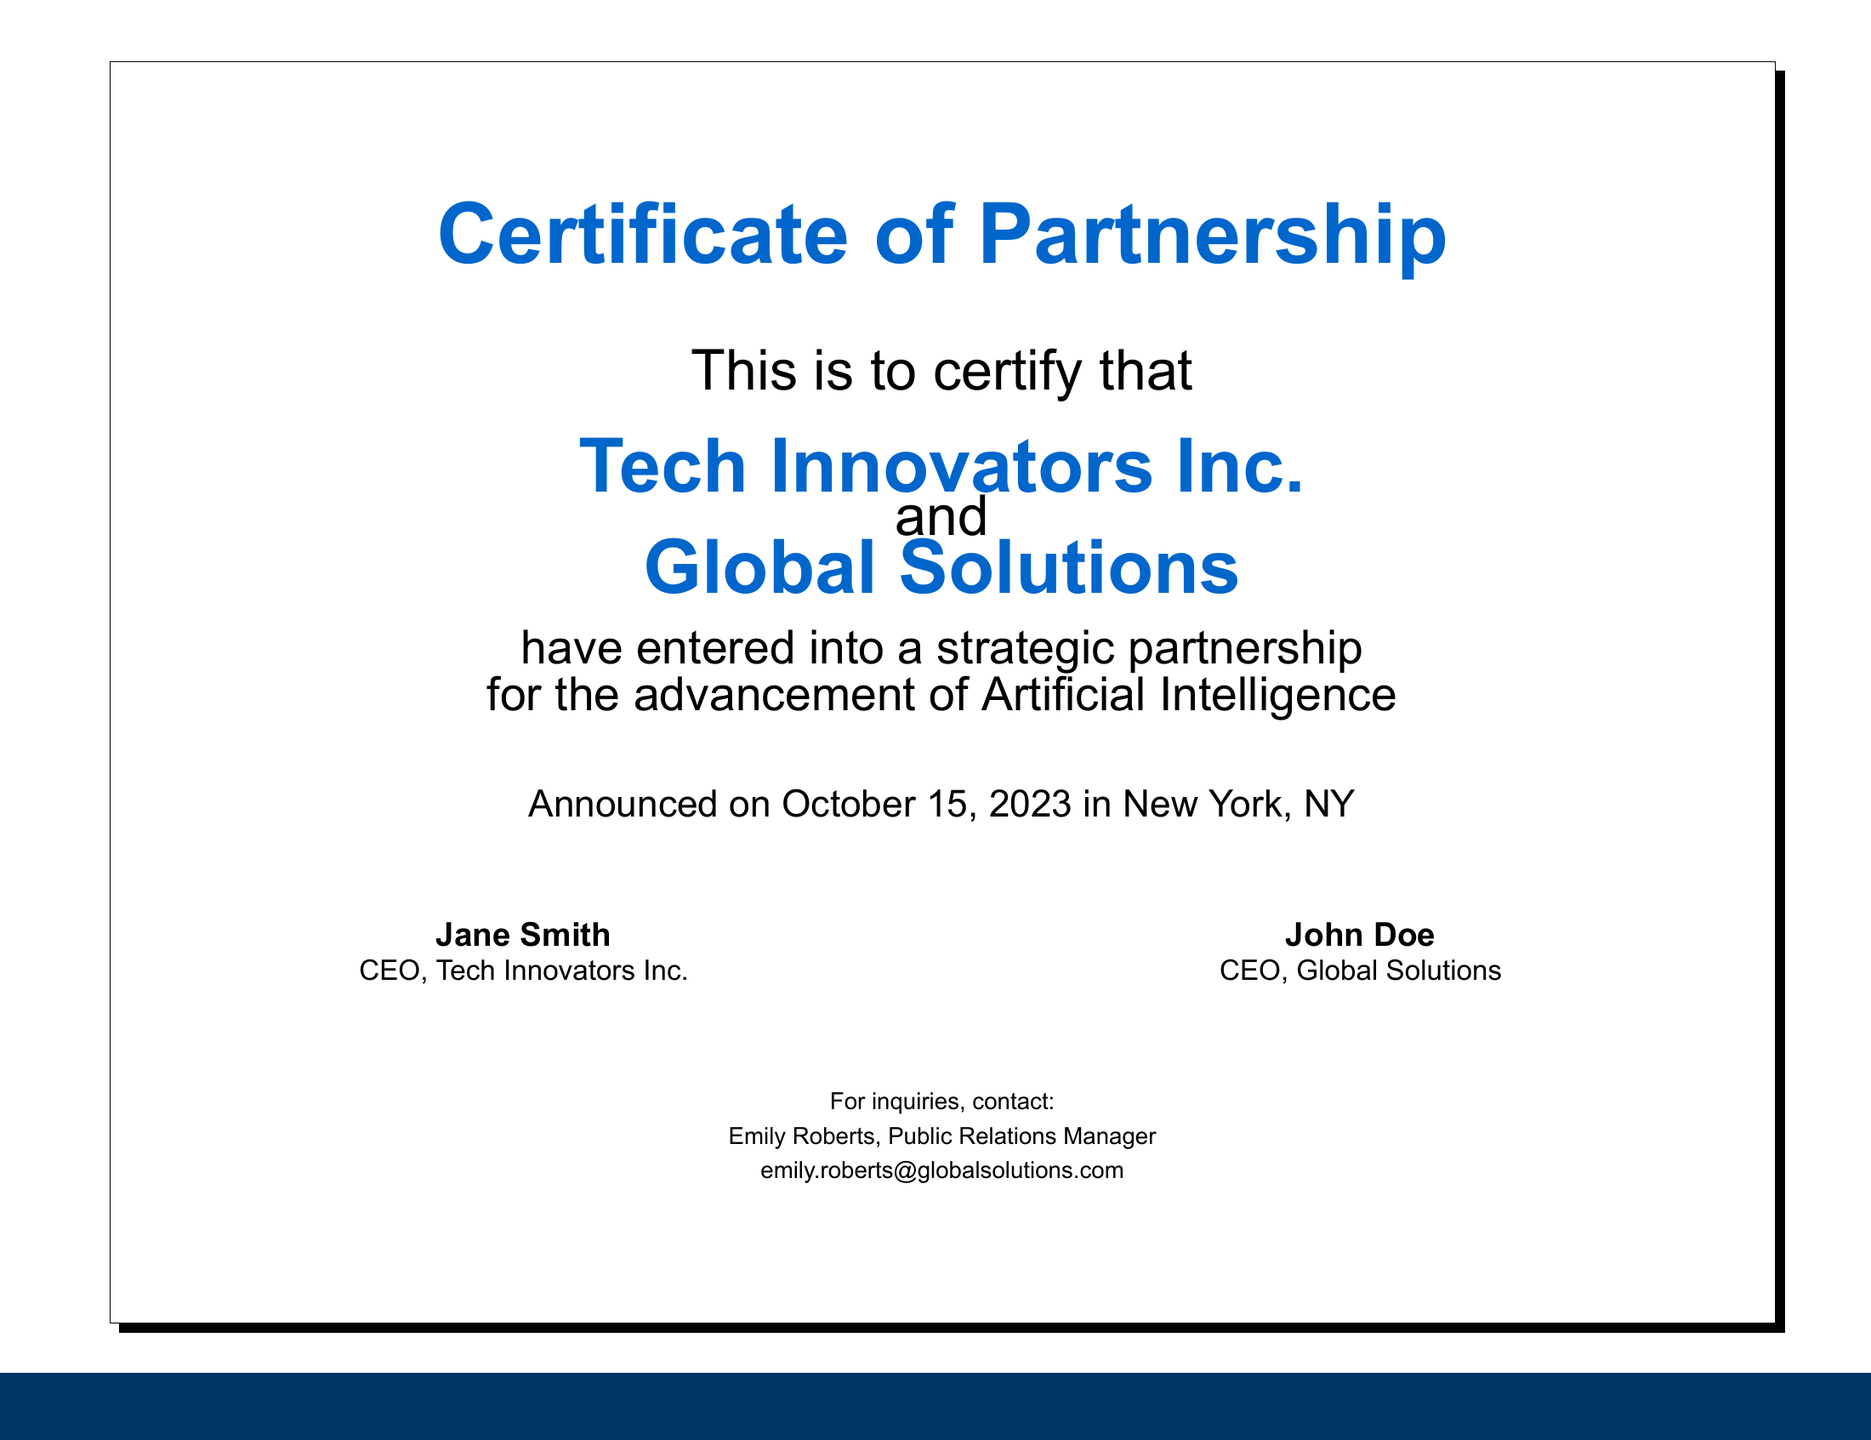What is the name of the first organization mentioned? The first organization mentioned in the document is Tech Innovators Inc.
Answer: Tech Innovators Inc Who are the CEOs of the two organizations? The document lists Jane Smith as the CEO of Tech Innovators Inc. and John Doe as the CEO of Global Solutions.
Answer: Jane Smith and John Doe What is the subject of the partnership? The subject of the partnership is for the advancement of Artificial Intelligence.
Answer: Artificial Intelligence When was the announcement made? The announcement was made on October 15, 2023.
Answer: October 15, 2023 Who should be contacted for inquiries? The document specifies Emily Roberts as the contact person for inquiries.
Answer: Emily Roberts What is the email address provided for inquiries? The email address given for inquiries is emily.roberts@globalsolutions.com.
Answer: emily.roberts@globalsolutions.com What is the location of the announcement? The location where the announcement was made is New York, NY.
Answer: New York, NY What type of document is this? The document certifies a partnership between two organizations, serving as a Certificate of Partnership.
Answer: Certificate of Partnership 